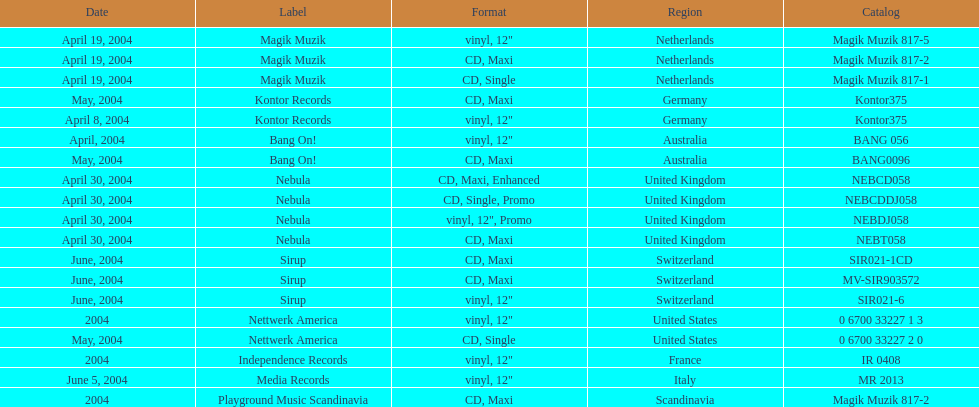What region was in the sir021-1cd catalog? Switzerland. 